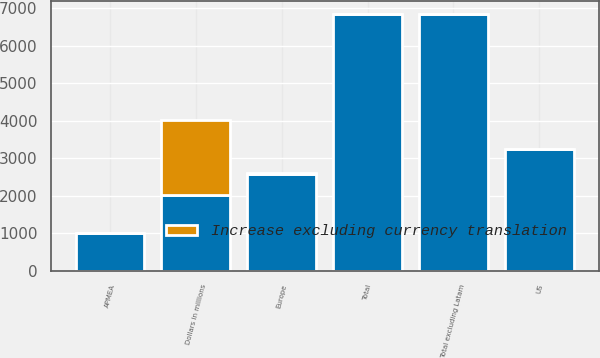<chart> <loc_0><loc_0><loc_500><loc_500><stacked_bar_chart><ecel><fcel>Dollars in millions<fcel>US<fcel>Europe<fcel>APMEA<fcel>Total<fcel>Total excluding Latam<nl><fcel>nan<fcel>2009<fcel>3232<fcel>2588<fcel>989<fcel>6841<fcel>6841<nl><fcel>Increase excluding currency translation<fcel>2009<fcel>6<fcel>8<fcel>23<fcel>10<fcel>10<nl></chart> 